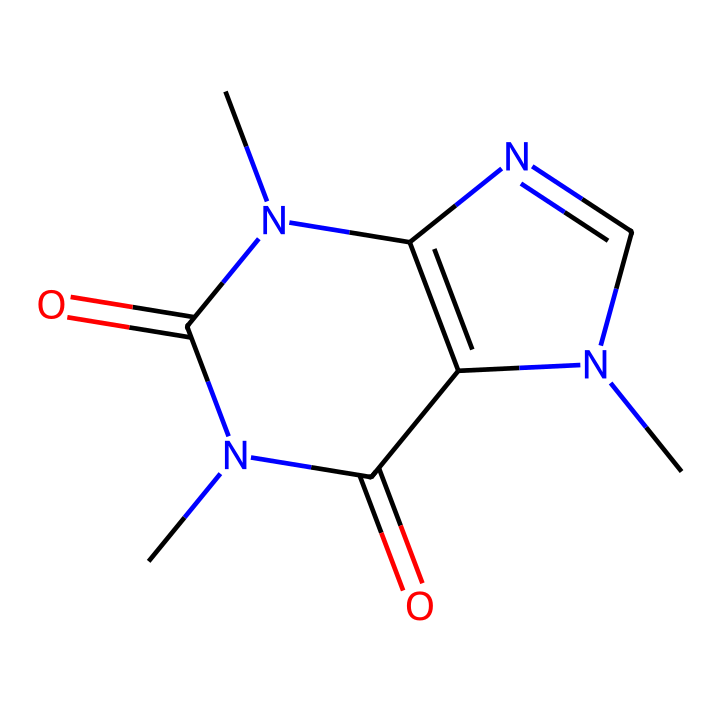What is the molecular formula of caffeine? To determine the molecular formula, count the number of each type of atom present in the structure provided. In this case, there are 8 carbon (C) atoms, 10 hydrogen (H) atoms, 4 nitrogen (N) atoms, and 2 oxygen (O) atoms. Thus, the molecular formula is C8H10N4O2.
Answer: C8H10N4O2 How many nitrogen atoms are in caffeine? From analyzing the structure, you can identify 4 distinct nitrogen atoms represented in the SMILES notation.
Answer: 4 What type of bonding is present in caffeine? The structure shows multiple interconnected atoms with single and double bonds. Therefore, caffeine exhibits covalent bonding as atoms share electrons.
Answer: covalent Is caffeine a solid, liquid, or gas at room temperature? Based on its properties and common state at room temperature, caffeine is typically a solid.
Answer: solid What is the functional group present in caffeine? Caffeine contains an amine functional group due to the presence of nitrogen atoms connected to hydrogen. This is characteristic of many alkaloids.
Answer: amine How many rings are present in the molecular structure of caffeine? If we review the structure, we can see that it consists of two interconnected rings which are characteristic of its xanthine structure.
Answer: 2 What does the presence of nitrogen suggest about caffeine's properties? The presence of nitrogen indicates that caffeine is an alkaloid, which typically contributes to physiological effects like stimulating the central nervous system.
Answer: alkaloid 